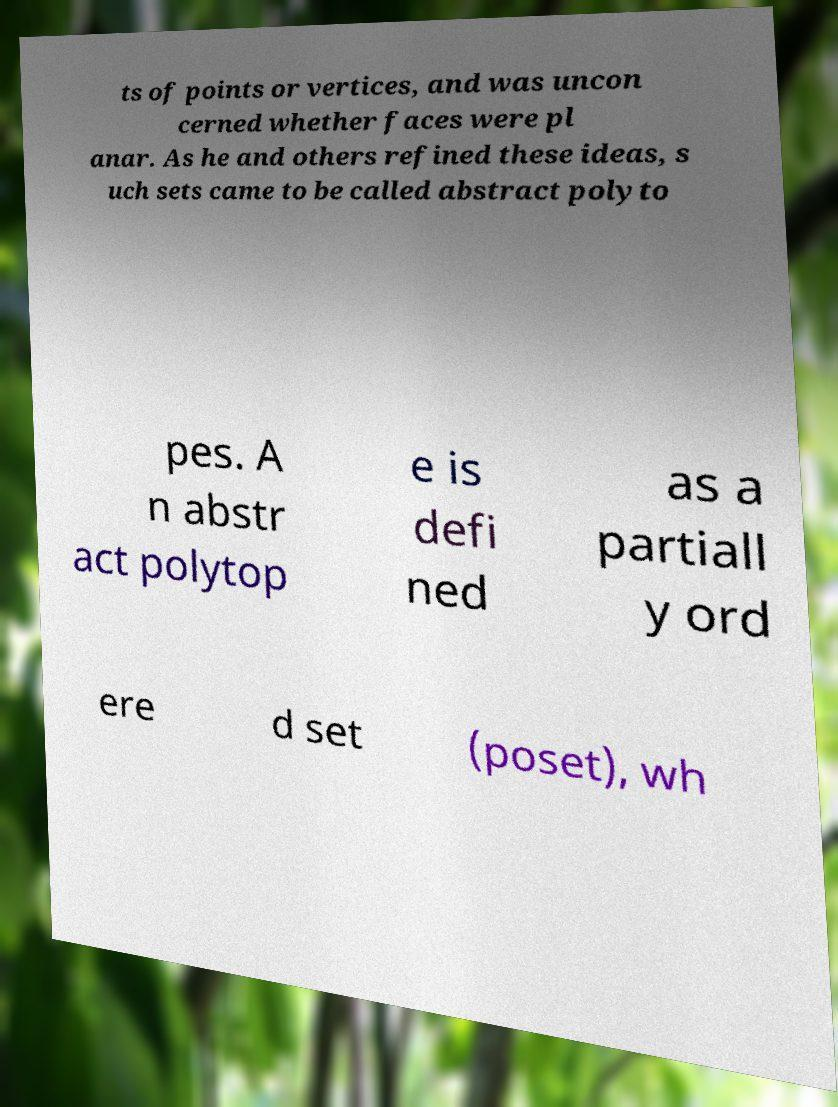Can you accurately transcribe the text from the provided image for me? ts of points or vertices, and was uncon cerned whether faces were pl anar. As he and others refined these ideas, s uch sets came to be called abstract polyto pes. A n abstr act polytop e is defi ned as a partiall y ord ere d set (poset), wh 